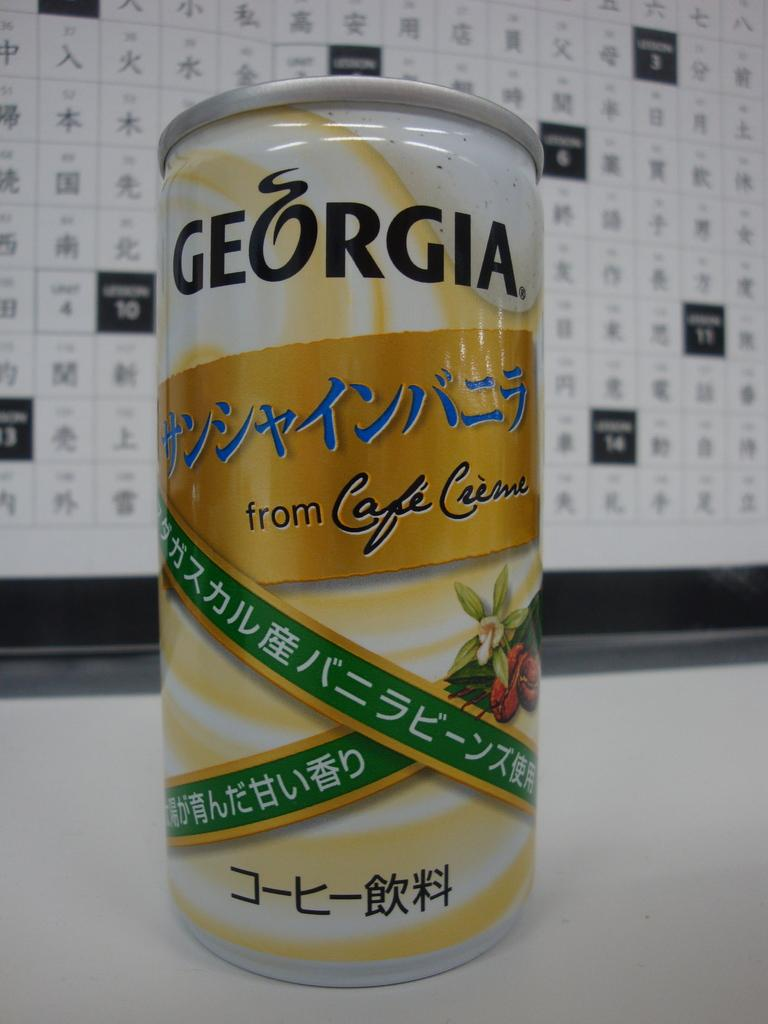<image>
Provide a brief description of the given image. A can of Georgia sitting in front of a chart 